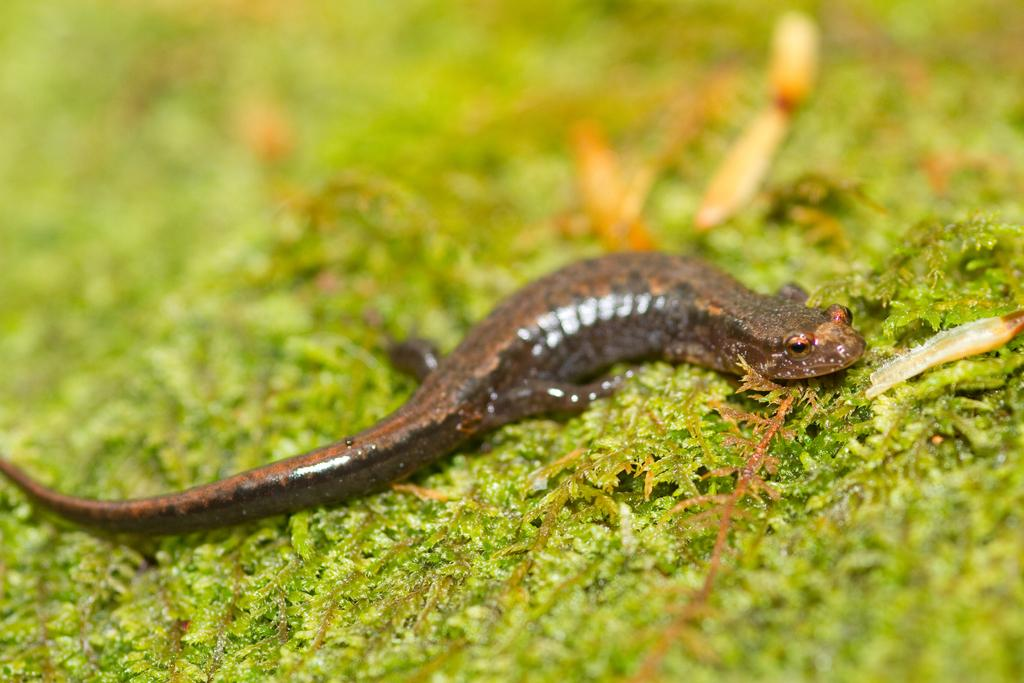What type of animal is in the picture? There is a salamander in the picture. What is the salamander resting on? The salamander is on a green surface or grass. How would you describe the background of the image? The surroundings of the image are blurred. What type of attraction can be seen in the background of the image? There is no attraction visible in the background of the image; the surroundings are blurred. 